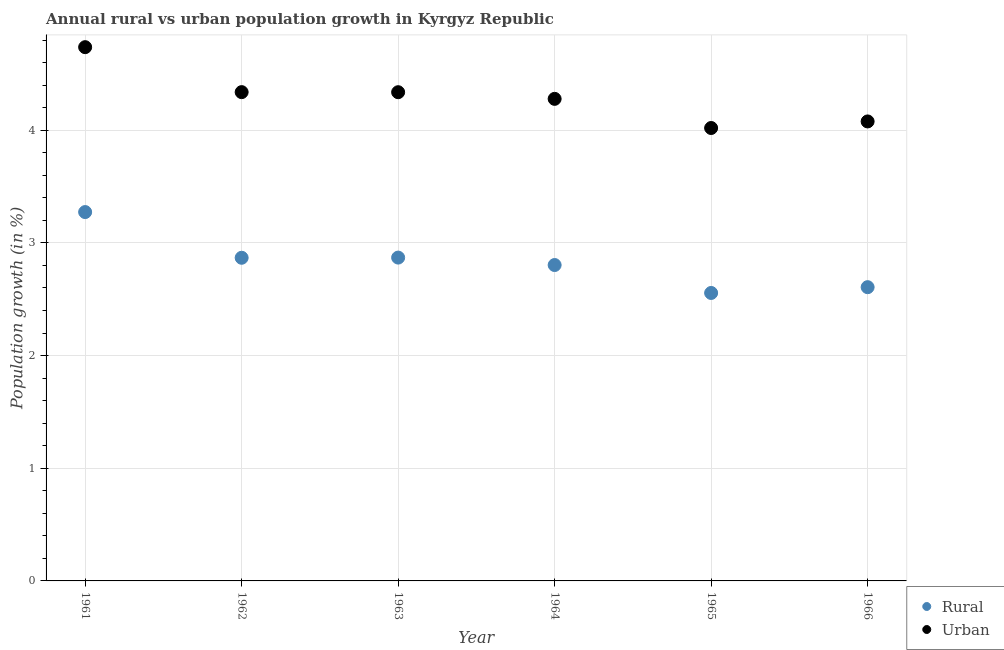What is the urban population growth in 1963?
Offer a terse response. 4.34. Across all years, what is the maximum rural population growth?
Your answer should be compact. 3.27. Across all years, what is the minimum urban population growth?
Keep it short and to the point. 4.02. In which year was the urban population growth minimum?
Offer a very short reply. 1965. What is the total urban population growth in the graph?
Offer a terse response. 25.79. What is the difference between the rural population growth in 1962 and that in 1963?
Your response must be concise. -0. What is the difference between the urban population growth in 1966 and the rural population growth in 1965?
Offer a very short reply. 1.52. What is the average urban population growth per year?
Offer a terse response. 4.3. In the year 1963, what is the difference between the urban population growth and rural population growth?
Offer a very short reply. 1.47. What is the ratio of the urban population growth in 1962 to that in 1966?
Offer a terse response. 1.06. Is the difference between the rural population growth in 1962 and 1963 greater than the difference between the urban population growth in 1962 and 1963?
Provide a succinct answer. No. What is the difference between the highest and the second highest rural population growth?
Keep it short and to the point. 0.4. What is the difference between the highest and the lowest rural population growth?
Provide a succinct answer. 0.72. In how many years, is the rural population growth greater than the average rural population growth taken over all years?
Your answer should be compact. 3. Is the sum of the urban population growth in 1964 and 1966 greater than the maximum rural population growth across all years?
Your response must be concise. Yes. Does the urban population growth monotonically increase over the years?
Your response must be concise. No. How many years are there in the graph?
Your answer should be very brief. 6. Does the graph contain grids?
Give a very brief answer. Yes. Where does the legend appear in the graph?
Ensure brevity in your answer.  Bottom right. How many legend labels are there?
Your answer should be compact. 2. What is the title of the graph?
Give a very brief answer. Annual rural vs urban population growth in Kyrgyz Republic. Does "Adolescent fertility rate" appear as one of the legend labels in the graph?
Make the answer very short. No. What is the label or title of the X-axis?
Your response must be concise. Year. What is the label or title of the Y-axis?
Your answer should be very brief. Population growth (in %). What is the Population growth (in %) of Rural in 1961?
Your answer should be very brief. 3.27. What is the Population growth (in %) of Urban  in 1961?
Your answer should be compact. 4.74. What is the Population growth (in %) of Rural in 1962?
Offer a terse response. 2.87. What is the Population growth (in %) of Urban  in 1962?
Provide a succinct answer. 4.34. What is the Population growth (in %) of Rural in 1963?
Your answer should be compact. 2.87. What is the Population growth (in %) of Urban  in 1963?
Provide a short and direct response. 4.34. What is the Population growth (in %) of Rural in 1964?
Ensure brevity in your answer.  2.8. What is the Population growth (in %) in Urban  in 1964?
Make the answer very short. 4.28. What is the Population growth (in %) in Rural in 1965?
Keep it short and to the point. 2.56. What is the Population growth (in %) in Urban  in 1965?
Your answer should be compact. 4.02. What is the Population growth (in %) in Rural in 1966?
Offer a very short reply. 2.61. What is the Population growth (in %) of Urban  in 1966?
Offer a very short reply. 4.08. Across all years, what is the maximum Population growth (in %) in Rural?
Give a very brief answer. 3.27. Across all years, what is the maximum Population growth (in %) in Urban ?
Keep it short and to the point. 4.74. Across all years, what is the minimum Population growth (in %) of Rural?
Your answer should be very brief. 2.56. Across all years, what is the minimum Population growth (in %) of Urban ?
Make the answer very short. 4.02. What is the total Population growth (in %) of Rural in the graph?
Offer a very short reply. 16.98. What is the total Population growth (in %) of Urban  in the graph?
Offer a very short reply. 25.79. What is the difference between the Population growth (in %) of Rural in 1961 and that in 1962?
Your response must be concise. 0.41. What is the difference between the Population growth (in %) of Urban  in 1961 and that in 1962?
Your answer should be very brief. 0.4. What is the difference between the Population growth (in %) in Rural in 1961 and that in 1963?
Provide a short and direct response. 0.4. What is the difference between the Population growth (in %) of Urban  in 1961 and that in 1963?
Offer a terse response. 0.4. What is the difference between the Population growth (in %) of Rural in 1961 and that in 1964?
Ensure brevity in your answer.  0.47. What is the difference between the Population growth (in %) in Urban  in 1961 and that in 1964?
Your answer should be compact. 0.46. What is the difference between the Population growth (in %) of Rural in 1961 and that in 1965?
Your answer should be very brief. 0.72. What is the difference between the Population growth (in %) of Urban  in 1961 and that in 1965?
Provide a short and direct response. 0.72. What is the difference between the Population growth (in %) of Rural in 1961 and that in 1966?
Offer a terse response. 0.67. What is the difference between the Population growth (in %) of Urban  in 1961 and that in 1966?
Ensure brevity in your answer.  0.66. What is the difference between the Population growth (in %) in Rural in 1962 and that in 1963?
Make the answer very short. -0. What is the difference between the Population growth (in %) in Urban  in 1962 and that in 1963?
Your answer should be very brief. 0. What is the difference between the Population growth (in %) of Rural in 1962 and that in 1964?
Offer a terse response. 0.06. What is the difference between the Population growth (in %) of Urban  in 1962 and that in 1964?
Offer a terse response. 0.06. What is the difference between the Population growth (in %) in Rural in 1962 and that in 1965?
Keep it short and to the point. 0.31. What is the difference between the Population growth (in %) in Urban  in 1962 and that in 1965?
Your response must be concise. 0.32. What is the difference between the Population growth (in %) of Rural in 1962 and that in 1966?
Provide a succinct answer. 0.26. What is the difference between the Population growth (in %) in Urban  in 1962 and that in 1966?
Provide a short and direct response. 0.26. What is the difference between the Population growth (in %) in Rural in 1963 and that in 1964?
Provide a succinct answer. 0.07. What is the difference between the Population growth (in %) in Urban  in 1963 and that in 1964?
Ensure brevity in your answer.  0.06. What is the difference between the Population growth (in %) of Rural in 1963 and that in 1965?
Provide a short and direct response. 0.31. What is the difference between the Population growth (in %) in Urban  in 1963 and that in 1965?
Ensure brevity in your answer.  0.32. What is the difference between the Population growth (in %) in Rural in 1963 and that in 1966?
Offer a very short reply. 0.26. What is the difference between the Population growth (in %) in Urban  in 1963 and that in 1966?
Your answer should be compact. 0.26. What is the difference between the Population growth (in %) of Rural in 1964 and that in 1965?
Ensure brevity in your answer.  0.25. What is the difference between the Population growth (in %) of Urban  in 1964 and that in 1965?
Offer a terse response. 0.26. What is the difference between the Population growth (in %) in Rural in 1964 and that in 1966?
Ensure brevity in your answer.  0.2. What is the difference between the Population growth (in %) in Urban  in 1964 and that in 1966?
Provide a succinct answer. 0.2. What is the difference between the Population growth (in %) of Rural in 1965 and that in 1966?
Ensure brevity in your answer.  -0.05. What is the difference between the Population growth (in %) in Urban  in 1965 and that in 1966?
Provide a succinct answer. -0.06. What is the difference between the Population growth (in %) in Rural in 1961 and the Population growth (in %) in Urban  in 1962?
Your response must be concise. -1.06. What is the difference between the Population growth (in %) of Rural in 1961 and the Population growth (in %) of Urban  in 1963?
Make the answer very short. -1.06. What is the difference between the Population growth (in %) of Rural in 1961 and the Population growth (in %) of Urban  in 1964?
Provide a short and direct response. -1. What is the difference between the Population growth (in %) of Rural in 1961 and the Population growth (in %) of Urban  in 1965?
Provide a succinct answer. -0.75. What is the difference between the Population growth (in %) of Rural in 1961 and the Population growth (in %) of Urban  in 1966?
Your answer should be compact. -0.8. What is the difference between the Population growth (in %) in Rural in 1962 and the Population growth (in %) in Urban  in 1963?
Your response must be concise. -1.47. What is the difference between the Population growth (in %) in Rural in 1962 and the Population growth (in %) in Urban  in 1964?
Your answer should be compact. -1.41. What is the difference between the Population growth (in %) of Rural in 1962 and the Population growth (in %) of Urban  in 1965?
Your answer should be very brief. -1.15. What is the difference between the Population growth (in %) of Rural in 1962 and the Population growth (in %) of Urban  in 1966?
Your answer should be compact. -1.21. What is the difference between the Population growth (in %) in Rural in 1963 and the Population growth (in %) in Urban  in 1964?
Offer a very short reply. -1.41. What is the difference between the Population growth (in %) of Rural in 1963 and the Population growth (in %) of Urban  in 1965?
Provide a short and direct response. -1.15. What is the difference between the Population growth (in %) in Rural in 1963 and the Population growth (in %) in Urban  in 1966?
Your answer should be compact. -1.21. What is the difference between the Population growth (in %) in Rural in 1964 and the Population growth (in %) in Urban  in 1965?
Your response must be concise. -1.22. What is the difference between the Population growth (in %) in Rural in 1964 and the Population growth (in %) in Urban  in 1966?
Your response must be concise. -1.27. What is the difference between the Population growth (in %) in Rural in 1965 and the Population growth (in %) in Urban  in 1966?
Your answer should be very brief. -1.52. What is the average Population growth (in %) of Rural per year?
Provide a succinct answer. 2.83. What is the average Population growth (in %) of Urban  per year?
Provide a succinct answer. 4.3. In the year 1961, what is the difference between the Population growth (in %) in Rural and Population growth (in %) in Urban ?
Offer a terse response. -1.46. In the year 1962, what is the difference between the Population growth (in %) of Rural and Population growth (in %) of Urban ?
Offer a terse response. -1.47. In the year 1963, what is the difference between the Population growth (in %) in Rural and Population growth (in %) in Urban ?
Provide a short and direct response. -1.47. In the year 1964, what is the difference between the Population growth (in %) of Rural and Population growth (in %) of Urban ?
Make the answer very short. -1.47. In the year 1965, what is the difference between the Population growth (in %) in Rural and Population growth (in %) in Urban ?
Make the answer very short. -1.46. In the year 1966, what is the difference between the Population growth (in %) of Rural and Population growth (in %) of Urban ?
Provide a short and direct response. -1.47. What is the ratio of the Population growth (in %) of Rural in 1961 to that in 1962?
Give a very brief answer. 1.14. What is the ratio of the Population growth (in %) of Urban  in 1961 to that in 1962?
Make the answer very short. 1.09. What is the ratio of the Population growth (in %) in Rural in 1961 to that in 1963?
Offer a terse response. 1.14. What is the ratio of the Population growth (in %) in Urban  in 1961 to that in 1963?
Ensure brevity in your answer.  1.09. What is the ratio of the Population growth (in %) of Rural in 1961 to that in 1964?
Make the answer very short. 1.17. What is the ratio of the Population growth (in %) in Urban  in 1961 to that in 1964?
Your response must be concise. 1.11. What is the ratio of the Population growth (in %) of Rural in 1961 to that in 1965?
Offer a terse response. 1.28. What is the ratio of the Population growth (in %) of Urban  in 1961 to that in 1965?
Offer a terse response. 1.18. What is the ratio of the Population growth (in %) of Rural in 1961 to that in 1966?
Ensure brevity in your answer.  1.26. What is the ratio of the Population growth (in %) of Urban  in 1961 to that in 1966?
Provide a short and direct response. 1.16. What is the ratio of the Population growth (in %) in Rural in 1962 to that in 1963?
Ensure brevity in your answer.  1. What is the ratio of the Population growth (in %) in Urban  in 1962 to that in 1964?
Offer a terse response. 1.01. What is the ratio of the Population growth (in %) of Rural in 1962 to that in 1965?
Your response must be concise. 1.12. What is the ratio of the Population growth (in %) of Urban  in 1962 to that in 1965?
Offer a very short reply. 1.08. What is the ratio of the Population growth (in %) of Rural in 1962 to that in 1966?
Keep it short and to the point. 1.1. What is the ratio of the Population growth (in %) in Urban  in 1962 to that in 1966?
Provide a short and direct response. 1.06. What is the ratio of the Population growth (in %) in Rural in 1963 to that in 1964?
Your answer should be compact. 1.02. What is the ratio of the Population growth (in %) in Urban  in 1963 to that in 1964?
Ensure brevity in your answer.  1.01. What is the ratio of the Population growth (in %) of Rural in 1963 to that in 1965?
Your answer should be compact. 1.12. What is the ratio of the Population growth (in %) in Urban  in 1963 to that in 1965?
Ensure brevity in your answer.  1.08. What is the ratio of the Population growth (in %) in Rural in 1963 to that in 1966?
Your response must be concise. 1.1. What is the ratio of the Population growth (in %) in Urban  in 1963 to that in 1966?
Your answer should be compact. 1.06. What is the ratio of the Population growth (in %) in Rural in 1964 to that in 1965?
Give a very brief answer. 1.1. What is the ratio of the Population growth (in %) in Urban  in 1964 to that in 1965?
Give a very brief answer. 1.06. What is the ratio of the Population growth (in %) of Rural in 1964 to that in 1966?
Offer a terse response. 1.08. What is the ratio of the Population growth (in %) in Urban  in 1964 to that in 1966?
Make the answer very short. 1.05. What is the ratio of the Population growth (in %) in Rural in 1965 to that in 1966?
Provide a short and direct response. 0.98. What is the ratio of the Population growth (in %) of Urban  in 1965 to that in 1966?
Offer a terse response. 0.99. What is the difference between the highest and the second highest Population growth (in %) of Rural?
Keep it short and to the point. 0.4. What is the difference between the highest and the second highest Population growth (in %) in Urban ?
Give a very brief answer. 0.4. What is the difference between the highest and the lowest Population growth (in %) of Rural?
Give a very brief answer. 0.72. What is the difference between the highest and the lowest Population growth (in %) of Urban ?
Your response must be concise. 0.72. 